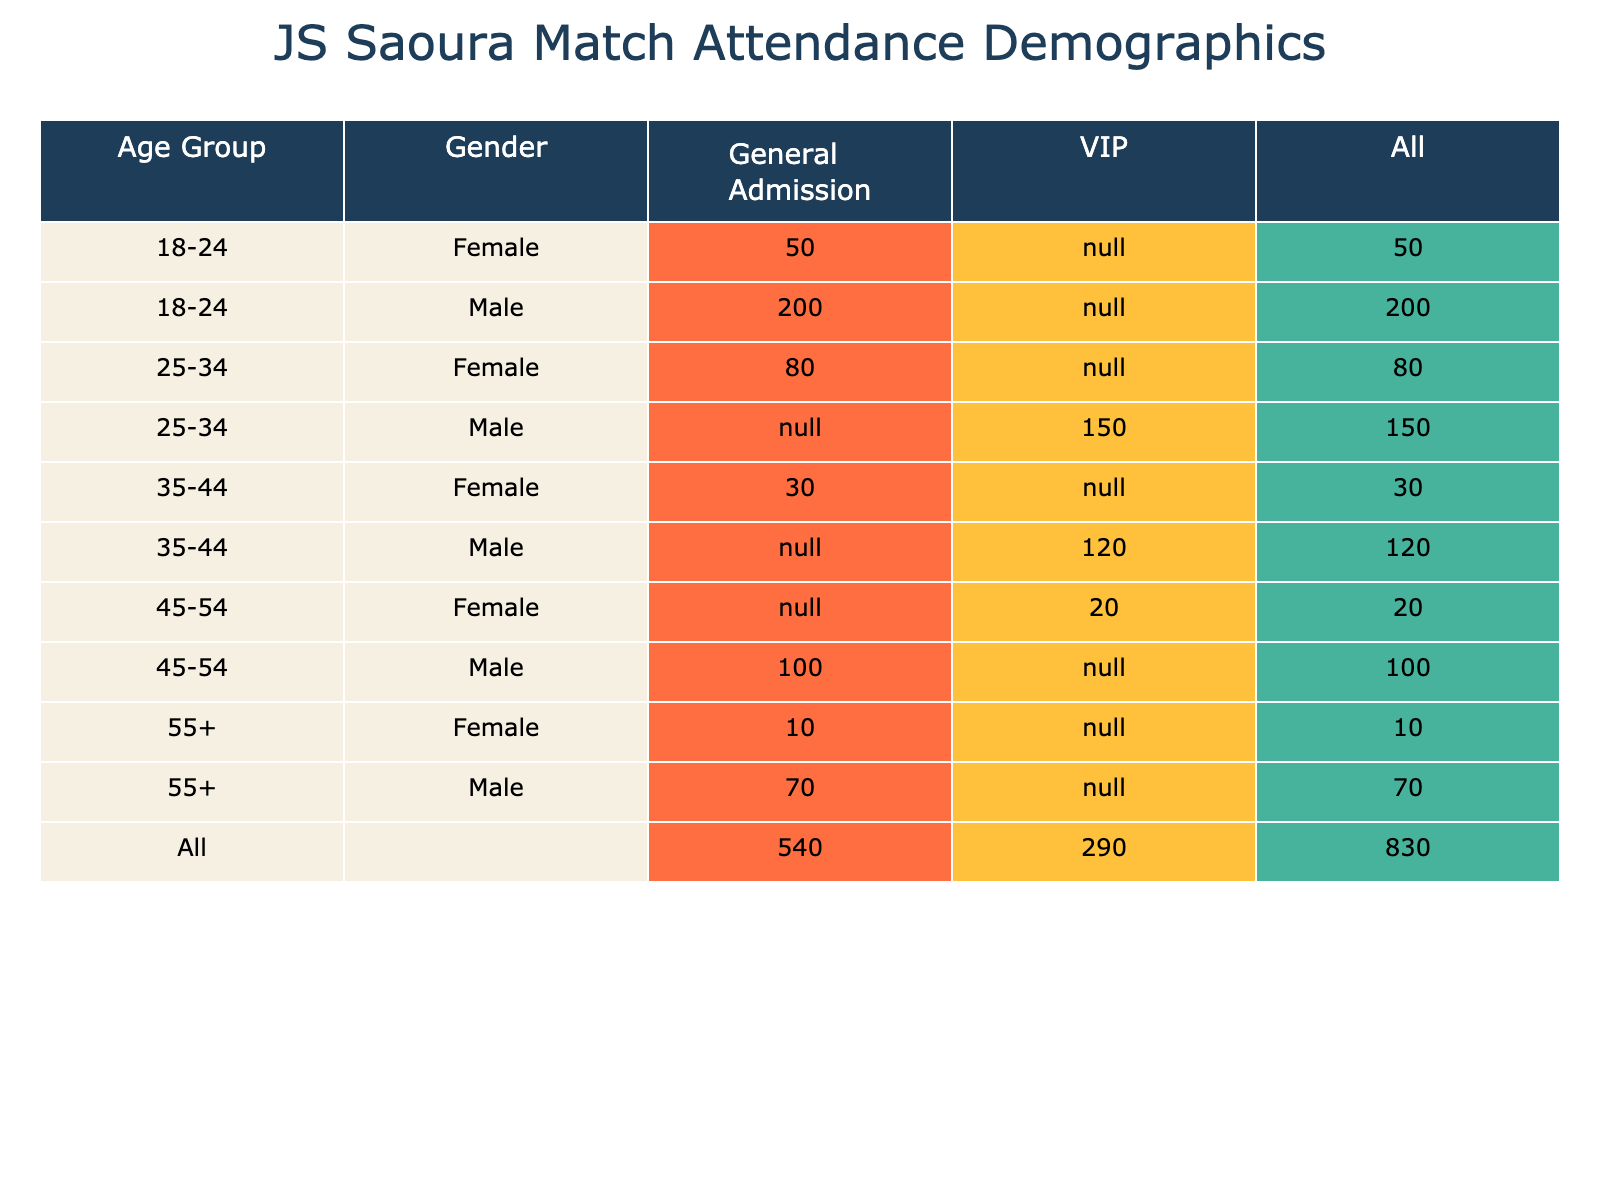What is the total attendance for the General Admission ticket type? To find the total attendance for General Admission, we sum up the values from the table under the General Admission column. The values are 200 (18-24 Male) + 50 (18-24 Female) + 80 (25-34 Female) + 100 (45-54 Male) + 70 (55+ Male) + 10 (55+ Female) + 30 (35-44 Female) = 200 + 50 + 80 + 100 + 70 + 10 + 30 = 540.
Answer: 540 How many males attended matches in the 25-34 age group? From the table, the value for males in the 25-34 age group is 150 in the VIP category. There are no other entries for males aged 25-34. Therefore, the attendance is simply 150.
Answer: 150 Is there a difference between the attendance of female VIPs and male VIPs? For females, the attendance in the VIP category is 20. For males, it is 150. The difference is calculated as 150 (Males) - 20 (Females) = 130.
Answer: Yes, the difference is 130 What age group had the highest total attendance, and what was that count? Analyzing the total attendance across age groups, we can calculate: for 18-24: 200 + 50 = 250, for 25-34: 150 + 80 = 230, for 35-44: 120 + 30 = 150, for 45-54: 100 + 20 = 120, and for 55+: 70 + 10 = 80. The highest total is from the 18-24 age group with 250 attendees.
Answer: 18-24 age group, 250 attendees What percentage of the total attendees were female? First, we find total female attendance: 50 (18-24) + 80 (25-34) + 30 (35-44) + 20 (45-54) + 10 (55+) = 190. The overall total is 540 (General Admission) + 150 (Male VIP) + 20 (Female VIP) = 710. The percentage is (190 / 710) * 100 ≈ 26.76%.
Answer: Approximately 26.76% How many attendees in total were older than 34 years old? Summing the values for age groups above 34: 120 (35-44 Male) + 30 (35-44 Female) + 100 (45-54 Male) + 20 (45-54 Female) + 70 (55+ Male) + 10 (55+ Female) = 350.
Answer: 350 